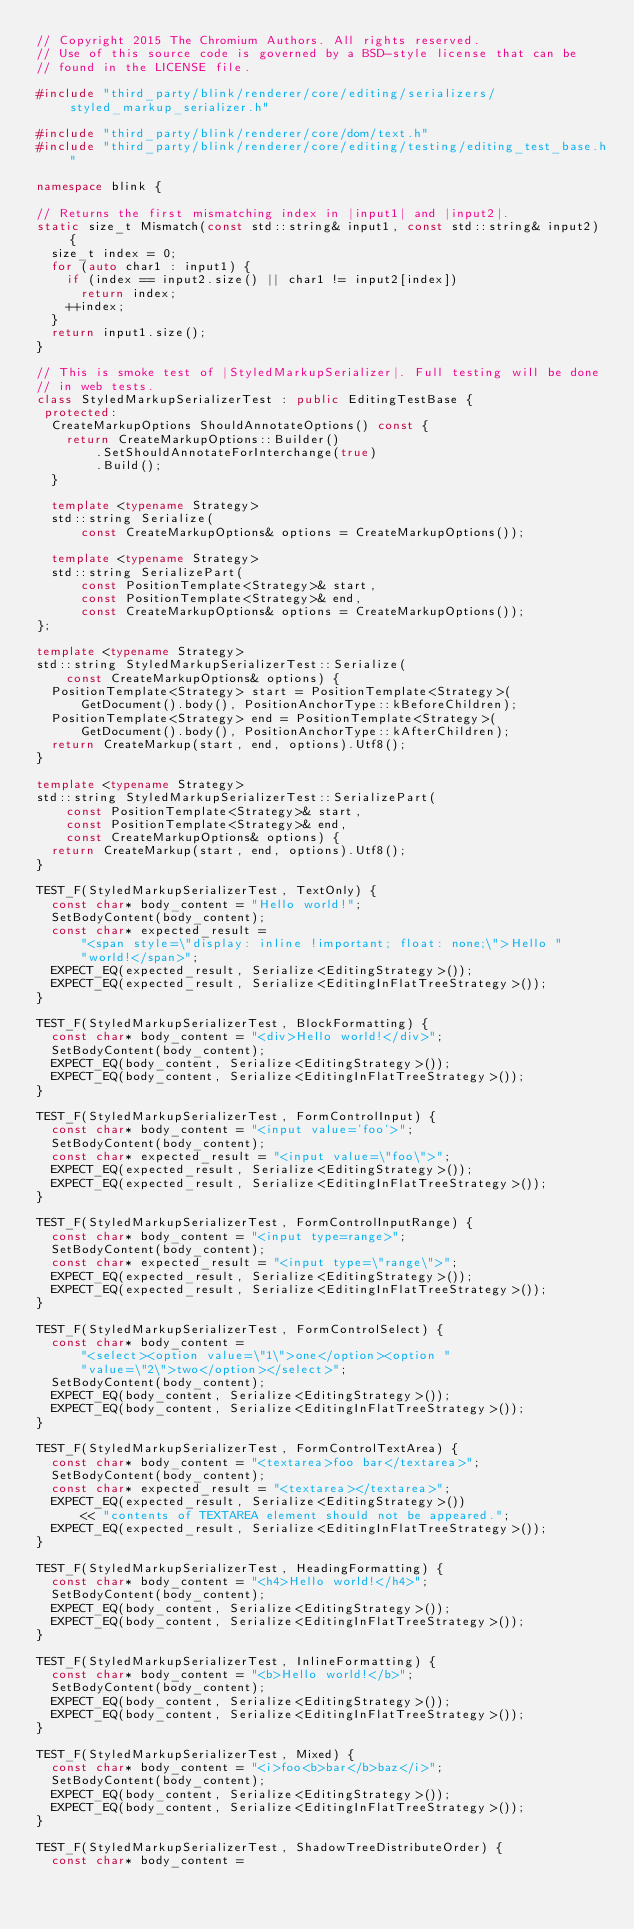Convert code to text. <code><loc_0><loc_0><loc_500><loc_500><_C++_>// Copyright 2015 The Chromium Authors. All rights reserved.
// Use of this source code is governed by a BSD-style license that can be
// found in the LICENSE file.

#include "third_party/blink/renderer/core/editing/serializers/styled_markup_serializer.h"

#include "third_party/blink/renderer/core/dom/text.h"
#include "third_party/blink/renderer/core/editing/testing/editing_test_base.h"

namespace blink {

// Returns the first mismatching index in |input1| and |input2|.
static size_t Mismatch(const std::string& input1, const std::string& input2) {
  size_t index = 0;
  for (auto char1 : input1) {
    if (index == input2.size() || char1 != input2[index])
      return index;
    ++index;
  }
  return input1.size();
}

// This is smoke test of |StyledMarkupSerializer|. Full testing will be done
// in web tests.
class StyledMarkupSerializerTest : public EditingTestBase {
 protected:
  CreateMarkupOptions ShouldAnnotateOptions() const {
    return CreateMarkupOptions::Builder()
        .SetShouldAnnotateForInterchange(true)
        .Build();
  }

  template <typename Strategy>
  std::string Serialize(
      const CreateMarkupOptions& options = CreateMarkupOptions());

  template <typename Strategy>
  std::string SerializePart(
      const PositionTemplate<Strategy>& start,
      const PositionTemplate<Strategy>& end,
      const CreateMarkupOptions& options = CreateMarkupOptions());
};

template <typename Strategy>
std::string StyledMarkupSerializerTest::Serialize(
    const CreateMarkupOptions& options) {
  PositionTemplate<Strategy> start = PositionTemplate<Strategy>(
      GetDocument().body(), PositionAnchorType::kBeforeChildren);
  PositionTemplate<Strategy> end = PositionTemplate<Strategy>(
      GetDocument().body(), PositionAnchorType::kAfterChildren);
  return CreateMarkup(start, end, options).Utf8();
}

template <typename Strategy>
std::string StyledMarkupSerializerTest::SerializePart(
    const PositionTemplate<Strategy>& start,
    const PositionTemplate<Strategy>& end,
    const CreateMarkupOptions& options) {
  return CreateMarkup(start, end, options).Utf8();
}

TEST_F(StyledMarkupSerializerTest, TextOnly) {
  const char* body_content = "Hello world!";
  SetBodyContent(body_content);
  const char* expected_result =
      "<span style=\"display: inline !important; float: none;\">Hello "
      "world!</span>";
  EXPECT_EQ(expected_result, Serialize<EditingStrategy>());
  EXPECT_EQ(expected_result, Serialize<EditingInFlatTreeStrategy>());
}

TEST_F(StyledMarkupSerializerTest, BlockFormatting) {
  const char* body_content = "<div>Hello world!</div>";
  SetBodyContent(body_content);
  EXPECT_EQ(body_content, Serialize<EditingStrategy>());
  EXPECT_EQ(body_content, Serialize<EditingInFlatTreeStrategy>());
}

TEST_F(StyledMarkupSerializerTest, FormControlInput) {
  const char* body_content = "<input value='foo'>";
  SetBodyContent(body_content);
  const char* expected_result = "<input value=\"foo\">";
  EXPECT_EQ(expected_result, Serialize<EditingStrategy>());
  EXPECT_EQ(expected_result, Serialize<EditingInFlatTreeStrategy>());
}

TEST_F(StyledMarkupSerializerTest, FormControlInputRange) {
  const char* body_content = "<input type=range>";
  SetBodyContent(body_content);
  const char* expected_result = "<input type=\"range\">";
  EXPECT_EQ(expected_result, Serialize<EditingStrategy>());
  EXPECT_EQ(expected_result, Serialize<EditingInFlatTreeStrategy>());
}

TEST_F(StyledMarkupSerializerTest, FormControlSelect) {
  const char* body_content =
      "<select><option value=\"1\">one</option><option "
      "value=\"2\">two</option></select>";
  SetBodyContent(body_content);
  EXPECT_EQ(body_content, Serialize<EditingStrategy>());
  EXPECT_EQ(body_content, Serialize<EditingInFlatTreeStrategy>());
}

TEST_F(StyledMarkupSerializerTest, FormControlTextArea) {
  const char* body_content = "<textarea>foo bar</textarea>";
  SetBodyContent(body_content);
  const char* expected_result = "<textarea></textarea>";
  EXPECT_EQ(expected_result, Serialize<EditingStrategy>())
      << "contents of TEXTAREA element should not be appeared.";
  EXPECT_EQ(expected_result, Serialize<EditingInFlatTreeStrategy>());
}

TEST_F(StyledMarkupSerializerTest, HeadingFormatting) {
  const char* body_content = "<h4>Hello world!</h4>";
  SetBodyContent(body_content);
  EXPECT_EQ(body_content, Serialize<EditingStrategy>());
  EXPECT_EQ(body_content, Serialize<EditingInFlatTreeStrategy>());
}

TEST_F(StyledMarkupSerializerTest, InlineFormatting) {
  const char* body_content = "<b>Hello world!</b>";
  SetBodyContent(body_content);
  EXPECT_EQ(body_content, Serialize<EditingStrategy>());
  EXPECT_EQ(body_content, Serialize<EditingInFlatTreeStrategy>());
}

TEST_F(StyledMarkupSerializerTest, Mixed) {
  const char* body_content = "<i>foo<b>bar</b>baz</i>";
  SetBodyContent(body_content);
  EXPECT_EQ(body_content, Serialize<EditingStrategy>());
  EXPECT_EQ(body_content, Serialize<EditingInFlatTreeStrategy>());
}

TEST_F(StyledMarkupSerializerTest, ShadowTreeDistributeOrder) {
  const char* body_content =</code> 